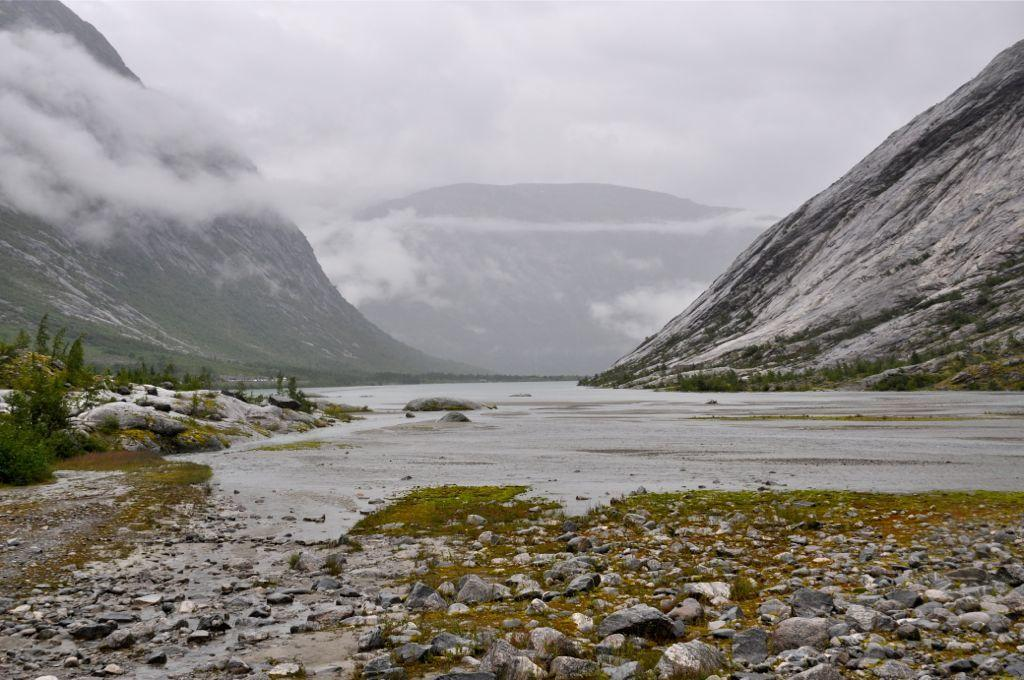What type of vegetation can be seen in the image? There is grass and plants visible in the image. What other natural elements can be seen in the image? There are rocks and water visible in the image. What is visible in the background of the image? There are mountains and the sky visible in the background of the image. What type of juice is being squeezed from the stem in the image? There is no juice or stem present in the image. 